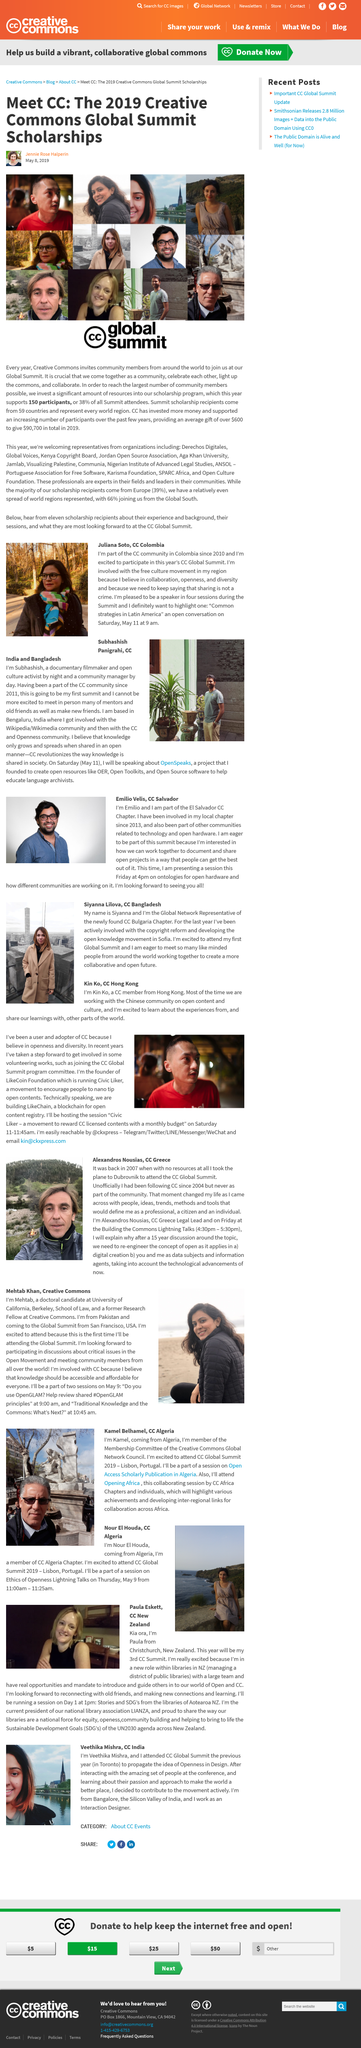Highlight a few significant elements in this photo. The subject is interested in documenting and sharing open projects. On May 9 at 9:00 am, the session will take place. The woman in the photo is named Juliana Soto. The scholarship program supports 150 participants. She attended the CC Global Summit in Toronto to promote the concept of Openness in Design. 